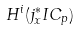<formula> <loc_0><loc_0><loc_500><loc_500>H ^ { i } ( j _ { x } ^ { * } I C _ { p } )</formula> 